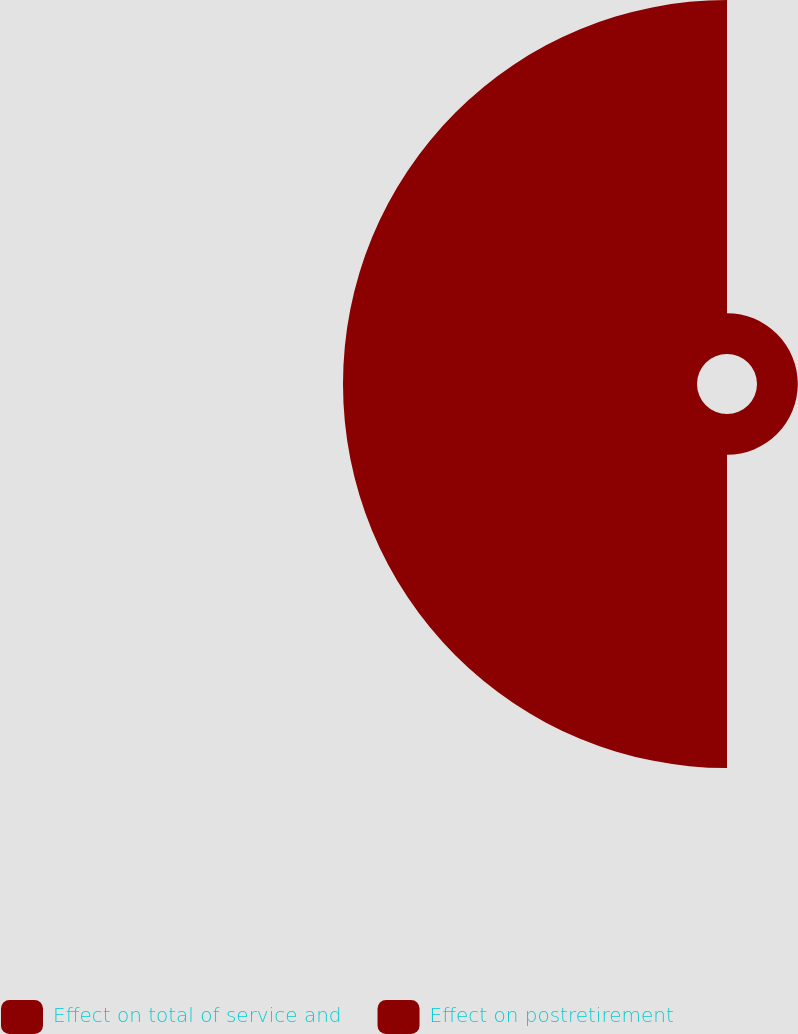<chart> <loc_0><loc_0><loc_500><loc_500><pie_chart><fcel>Effect on total of service and<fcel>Effect on postretirement<nl><fcel>10.33%<fcel>89.67%<nl></chart> 